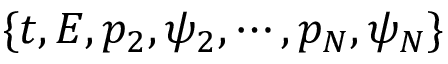Convert formula to latex. <formula><loc_0><loc_0><loc_500><loc_500>\{ t , E , p _ { 2 } , \psi _ { 2 } , \cdots , p _ { N } , \psi _ { N } \}</formula> 